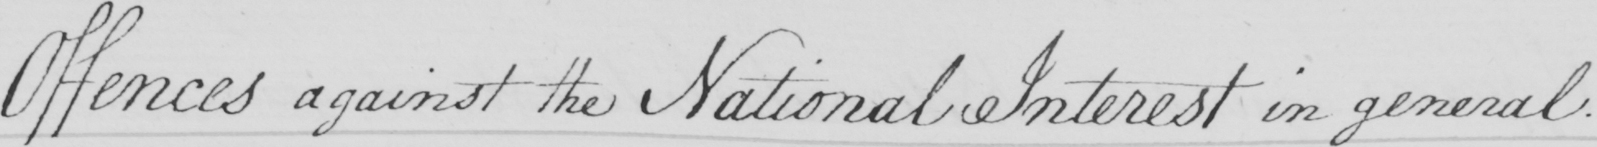What is written in this line of handwriting? Offences against the National Interest in general 